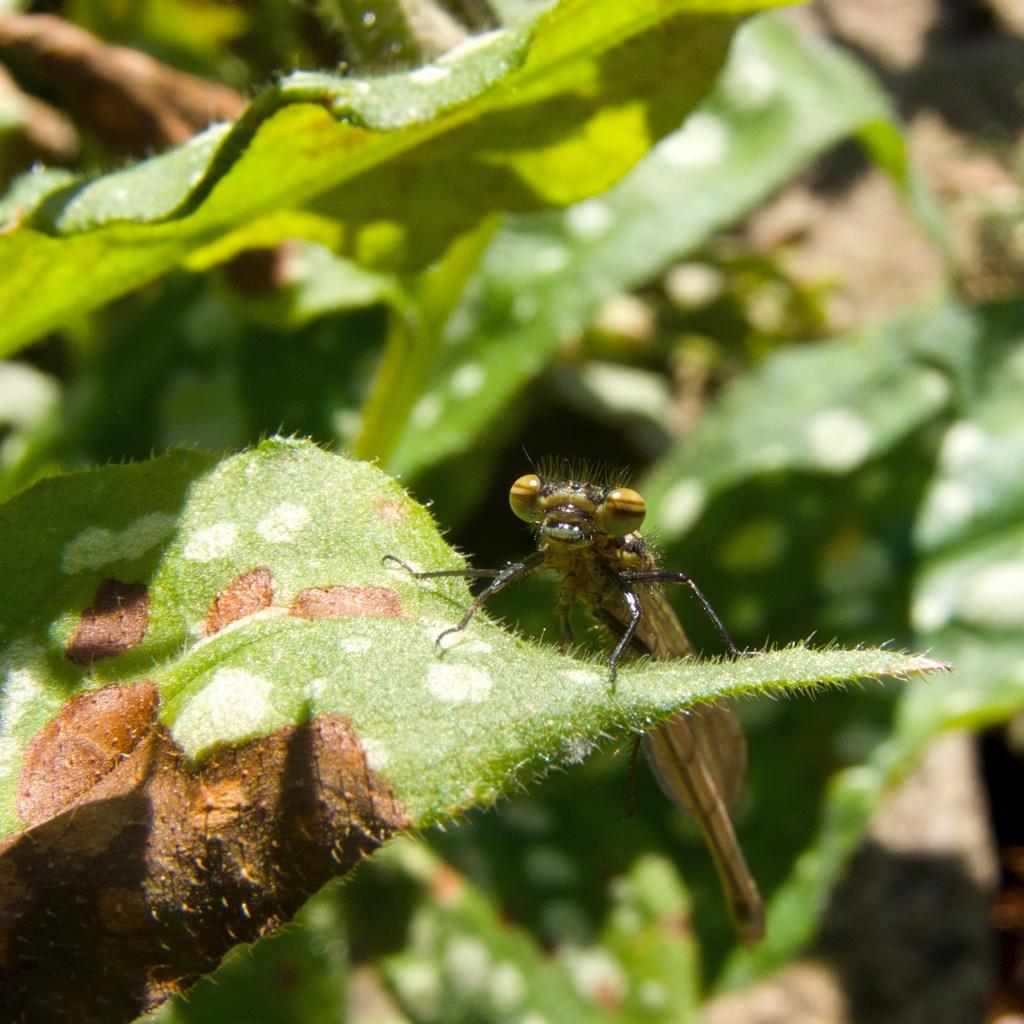What type of insect is in the image? There is a brown color grasshopper in the image. Where is the grasshopper located? The grasshopper is sitting on a green leaf. What else can be seen in the image besides the grasshopper? There are plant leaves visible in the image. What type of alarm is ringing in the image? There is no alarm present in the image; it features a grasshopper sitting on a leaf. What substance is being delivered in the image? There is no substance or parcel being delivered in the image; it only shows a grasshopper on a leaf. 